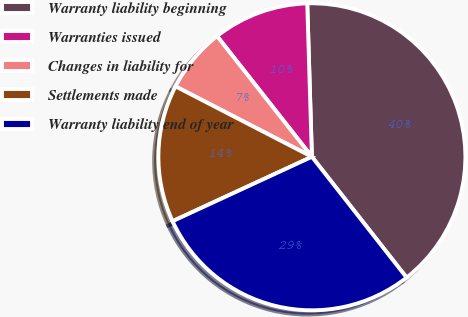Convert chart. <chart><loc_0><loc_0><loc_500><loc_500><pie_chart><fcel>Warranty liability beginning<fcel>Warranties issued<fcel>Changes in liability for<fcel>Settlements made<fcel>Warranty liability end of year<nl><fcel>39.9%<fcel>10.12%<fcel>6.81%<fcel>14.48%<fcel>28.69%<nl></chart> 